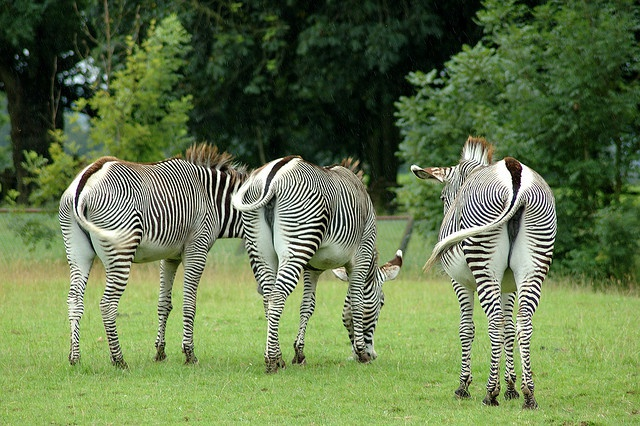Describe the objects in this image and their specific colors. I can see zebra in black, ivory, darkgray, and gray tones, zebra in black, ivory, darkgray, and gray tones, and zebra in black, ivory, darkgray, and gray tones in this image. 